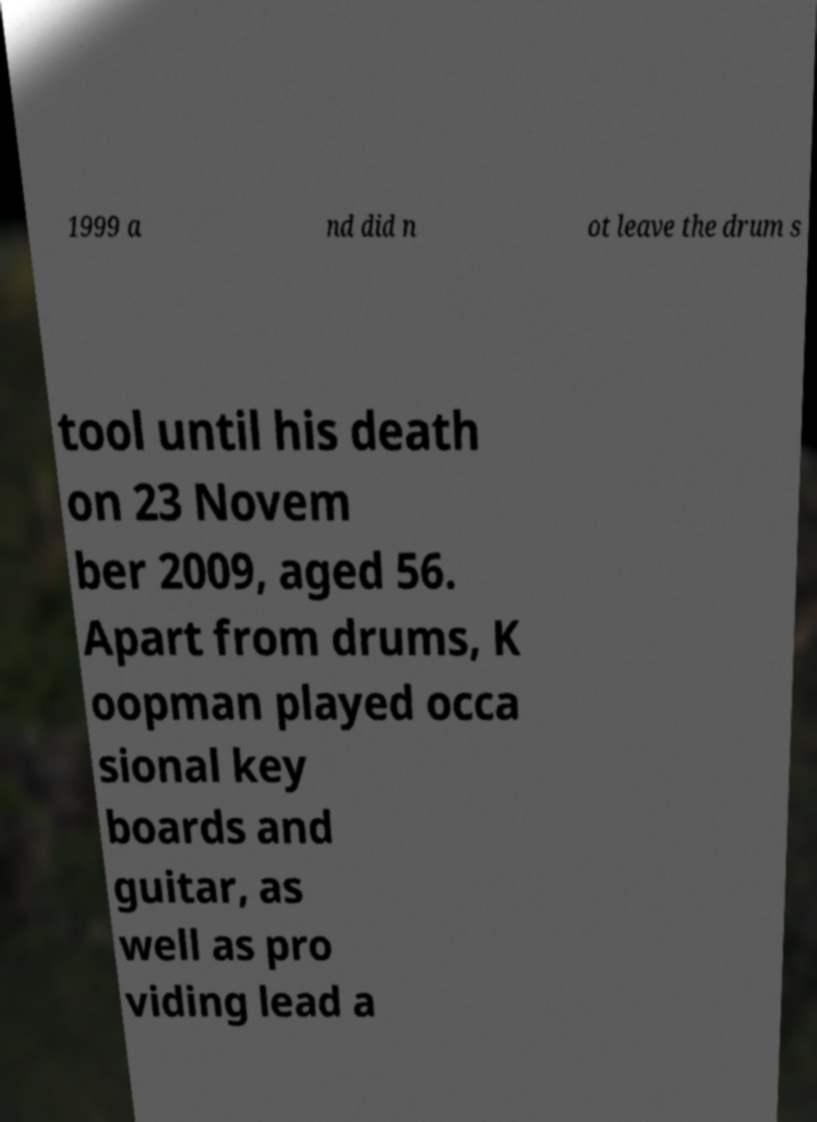Please read and relay the text visible in this image. What does it say? 1999 a nd did n ot leave the drum s tool until his death on 23 Novem ber 2009, aged 56. Apart from drums, K oopman played occa sional key boards and guitar, as well as pro viding lead a 